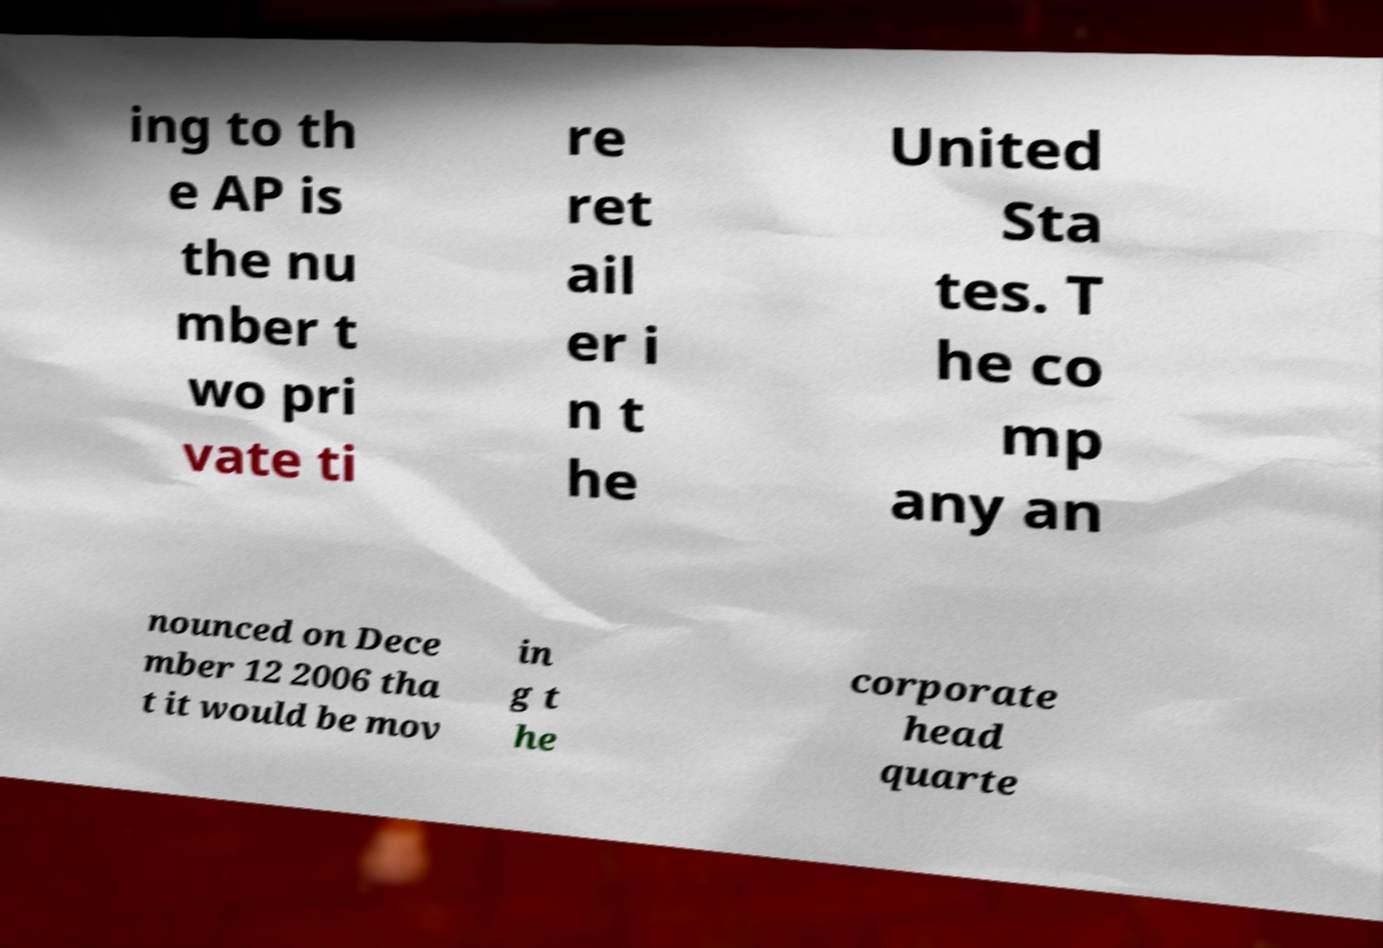Please read and relay the text visible in this image. What does it say? ing to th e AP is the nu mber t wo pri vate ti re ret ail er i n t he United Sta tes. T he co mp any an nounced on Dece mber 12 2006 tha t it would be mov in g t he corporate head quarte 